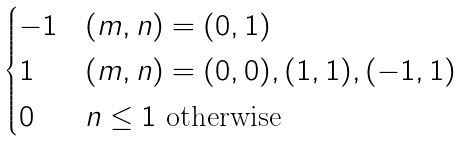Convert formula to latex. <formula><loc_0><loc_0><loc_500><loc_500>\begin{cases} - 1 & ( m , n ) = ( 0 , 1 ) \\ 1 & ( m , n ) = ( 0 , 0 ) , ( 1 , 1 ) , ( - 1 , 1 ) \\ 0 & n \leq 1 \text { otherwise} \end{cases}</formula> 